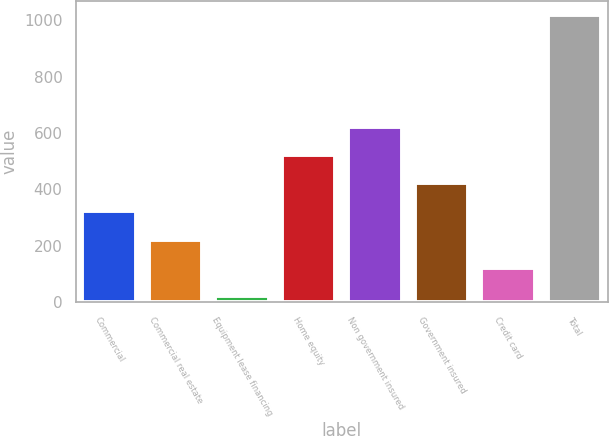Convert chart to OTSL. <chart><loc_0><loc_0><loc_500><loc_500><bar_chart><fcel>Commercial<fcel>Commercial real estate<fcel>Equipment lease financing<fcel>Home equity<fcel>Non government insured<fcel>Government insured<fcel>Credit card<fcel>Total<nl><fcel>320.8<fcel>221.2<fcel>22<fcel>520<fcel>619.6<fcel>420.4<fcel>121.6<fcel>1018<nl></chart> 